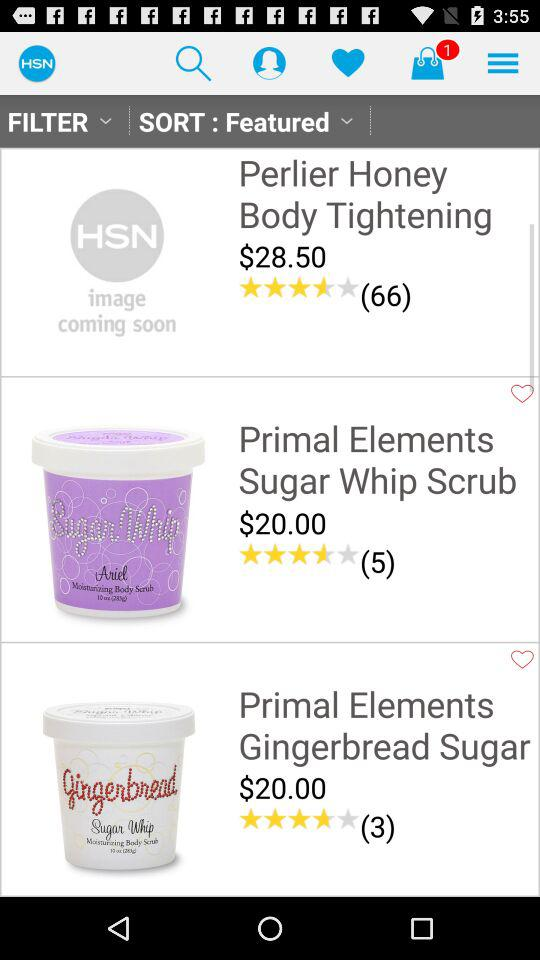How many items are in the bag? There is 1 item. 